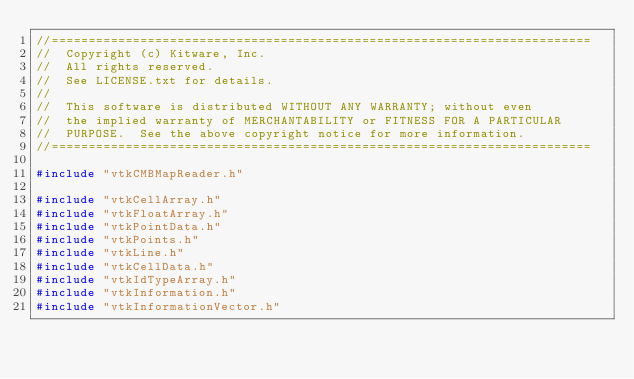<code> <loc_0><loc_0><loc_500><loc_500><_C++_>//=========================================================================
//  Copyright (c) Kitware, Inc.
//  All rights reserved.
//  See LICENSE.txt for details.
//
//  This software is distributed WITHOUT ANY WARRANTY; without even
//  the implied warranty of MERCHANTABILITY or FITNESS FOR A PARTICULAR
//  PURPOSE.  See the above copyright notice for more information.
//=========================================================================

#include "vtkCMBMapReader.h"

#include "vtkCellArray.h"
#include "vtkFloatArray.h"
#include "vtkPointData.h"
#include "vtkPoints.h"
#include "vtkLine.h"
#include "vtkCellData.h"
#include "vtkIdTypeArray.h"
#include "vtkInformation.h"
#include "vtkInformationVector.h"</code> 